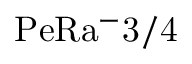<formula> <loc_0><loc_0><loc_500><loc_500>P e R a ^ { - } { 3 / 4 }</formula> 